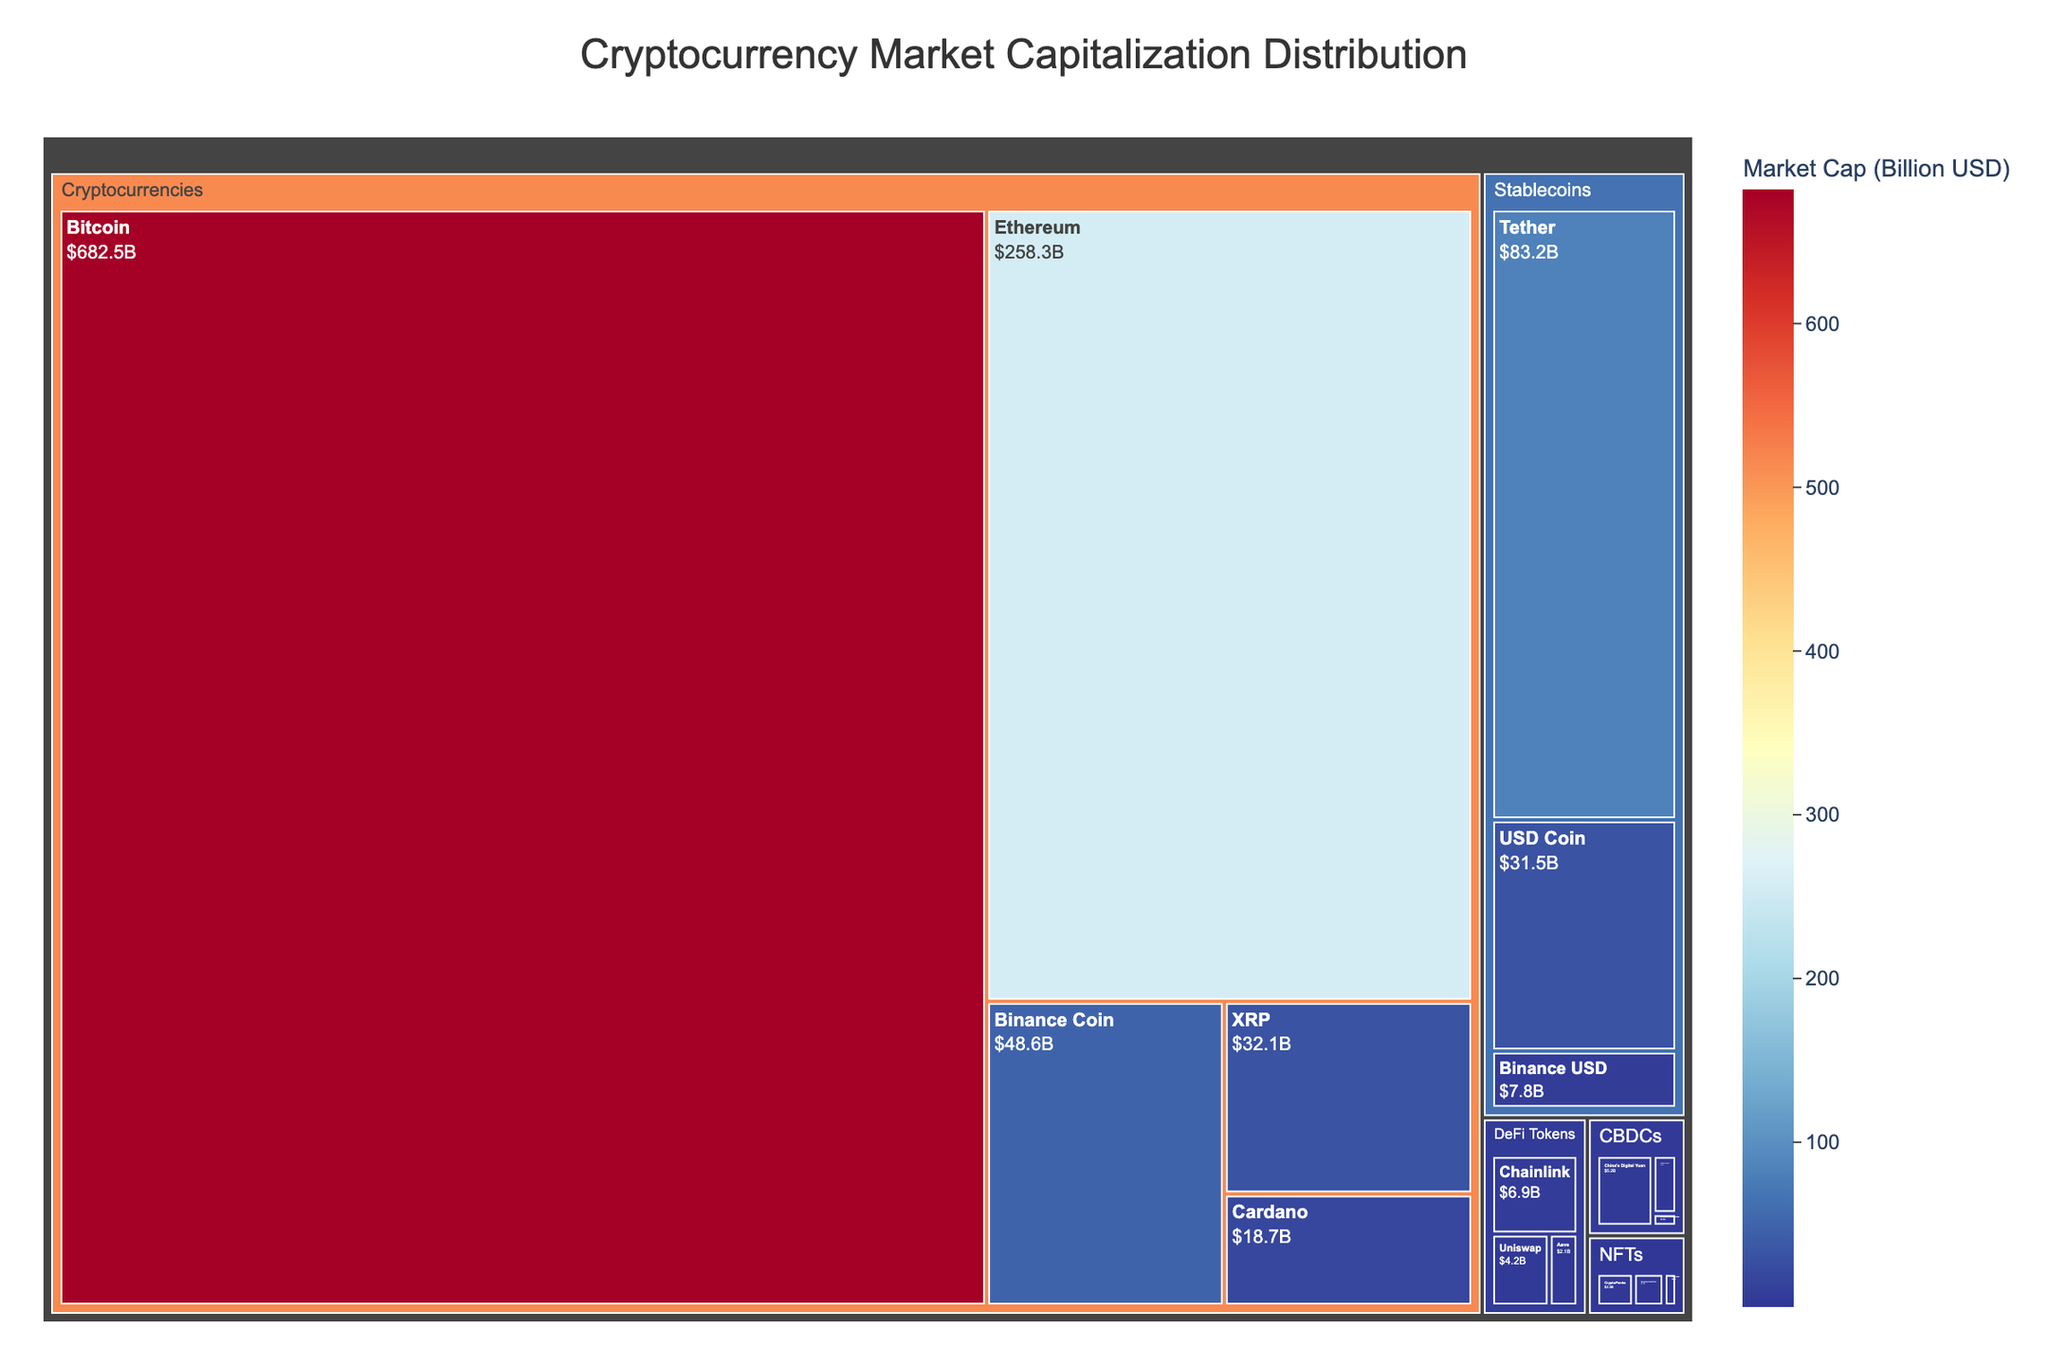What is the title of the treemap? The title of the treemap is usually displayed at the top center of the plot. Here it is "Cryptocurrency Market Capitalization Distribution".
Answer: Cryptocurrency Market Capitalization Distribution Which cryptocurrency has the highest market capitalization? By examining the size and labeling of the rectangles, the largest one in the "Cryptocurrencies" category is labeled "Bitcoin" with a market capitalization value of 682.5 billion USD.
Answer: Bitcoin What is the combined market capitalization of stablecoins in the treemap? Sum the market capitalization values of all subcategories under "Stablecoins" which are Tether (83.2), USD Coin (31.5), and Binance USD (7.8). The combined value is 83.2 + 31.5 + 7.8 = 122.5 billion USD.
Answer: 122.5 billion USD Which subcategory has the smallest market capitalization value? By looking at the smallest rectangle, "Bahamas Sand Dollar" in the "CBDCs" category has a value of 0.4 billion USD.
Answer: Bahamas Sand Dollar What is the total market capitalization of digital assets classified as CBDCs by summing the market cap values of each subcategory under "CBDCs"? The market cap for "China's Digital Yuan" is 5.2, "Sweden's e-krona" is 1.8, and "Bahamas Sand Dollar" is 0.4. The combined value is 5.2 + 1.8 + 0.4 = 7.4 billion USD.
Answer: 7.4 billion USD How does the market capitalization of Ethereum compare to that of Tether? Compare the values of Ethereum (258.3 billion USD) and Tether (83.2 billion USD). Ethereum's market cap is larger.
Answer: Ethereum is larger What is the market capitalization difference between Binance Coin and Cardano? The market cap of Binance Coin is 48.6 billion USD and Cardano is 18.7 billion USD. The difference is 48.6 - 18.7 = 29.9 billion USD.
Answer: 29.9 billion USD Identify the category with the most diverse subcategories by count. Count the subcategories under each category. "Cryptocurrencies" and "Stablecoins" each have more subcategories (5) compared to "CBDCs" (3) and "DeFi Tokens" (3).
Answer: Cryptocurrencies What is the average market capitalization of the NFTs subcategories? Sum the market cap values of "CryptoPunks" (2.3), "Bored Ape Yacht Club" (1.9), and "Art Blocks" (0.8). The total is 2.3 + 1.9 + 0.8 = 5.0. Divide by the number of subcategories, 5.0 / 3 = 1.67 billion USD.
Answer: 1.67 billion USD Between "Chainlink" and "Uniswap", which DeFi Token has a higher market value and by how much? "Chainlink" has a market cap of 6.9 billion USD, whereas "Uniswap" has 4.2 billion USD. Chainlink's market cap is higher by 6.9 - 4.2 = 2.7 billion USD.
Answer: Chainlink by 2.7 billion USD 